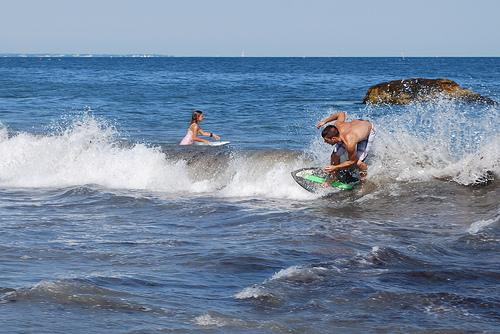How many waves in the ocean are visible in the image? There are 10 visible waves in the ocean. Provide a brief description of the weather and water conditions in the image. The image shows clear blue sunny cloudless sky, bright blue ocean water, and white crest of waves in the ocean water. Enumerate the colors of swimsuits or surf equipment and what gender the person is wearing them. A girl is in a white bathing suit, a shirtless man is in white shorts, a man is in plaid swim trunks, and a black surfboard has a lime green stripe. Describe the presence of rocks in the image. There are 2 rocks: one is a large brown rock in ocean water, and the other is a rock jutting out of the water. Estimate the number of people, waves, and ripples in the water, and specify the number of rocks visible. There are 2 people, 10 waves, 9 ripples, and 2 rocks visible in the image. Identify the number of people surfing in the ocean and the number of ripples in the water in the image. There are 2 people surfing in the ocean and 9 ripples in the water. Count the number of surfboards seen in the image and describe their appearance. There are 2 surfboards: one is white and used by the girl in the white bathing suit; and the other is black with a lime green stripe down the middle, used by the man with white shorts. What is the activity or interaction taking place in the foreground of the image? Two people, a man and a woman, are surfing in the ocean with their respective surfboards, while waves and ripples surround them. Describe the appearance and actions of the woman on the surfboard. The woman has a white bathing suit and a white surfboard, she is a young blond girl preparing to surf and has a black wrist band on. Analyze the image and describe any distinctive clothing or accessories worn by the people. The man has a black watch on his wrist, the girl has a black wrist band on, and the man with plaid swim trunks is also visible. Identify the bright red umbrella near the coastline and name the brand printed on it. No, it's not mentioned in the image. 